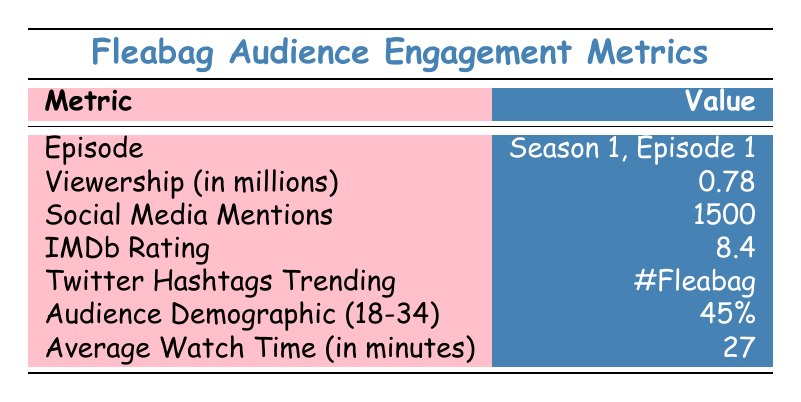What is the viewership for Season 1, Episode 1? The table specifies that the viewership for Season 1, Episode 1 is 0.78 million.
Answer: 0.78 million How many social media mentions did Season 1, Episode 1 receive? According to the table, Season 1, Episode 1 received 1500 social media mentions.
Answer: 1500 Was the IMDb rating for Season 1, Episode 1 higher than 8.0? The table indicates that the IMDb rating is 8.4, which is indeed higher than 8.0.
Answer: Yes What percentage of the audience demographic is between the ages of 18 and 34? The table shows that 45% of the audience demographic falls within the age range of 18 to 34.
Answer: 45% If the average watch time is 27 minutes, how many minutes of watch time would 5 episodes yield in total? To find the total watch time for 5 episodes, multiply the average watch time by the number of episodes: 27 minutes * 5 = 135 minutes.
Answer: 135 minutes If social media mentions increased by 20% after the first episode, what would the new total be? First, calculate 20% of 1500, which is 1500 * 0.20 = 300. Then add this to the original mentions: 1500 + 300 = 1800.
Answer: 1800 Is the Twitter hashtag trending for the episode "#Fleabag"? The table indicates that the trending hashtag for the episode is indeed "#Fleabag".
Answer: Yes Which metric has the highest value for Season 1, Episode 1? Comparing the values, the IMDb rating of 8.4 is the highest among all listed metrics.
Answer: IMDb Rating (8.4) What is the difference between the IMDb rating and the percentage of the audience demographic? The IMDb rating is 8.4, and the audience demographic percentage is 45. To find the difference, we must express 45% as a decimal (0.45) and calculate: 8.4 - 0.45 = 7.95.
Answer: 7.95 